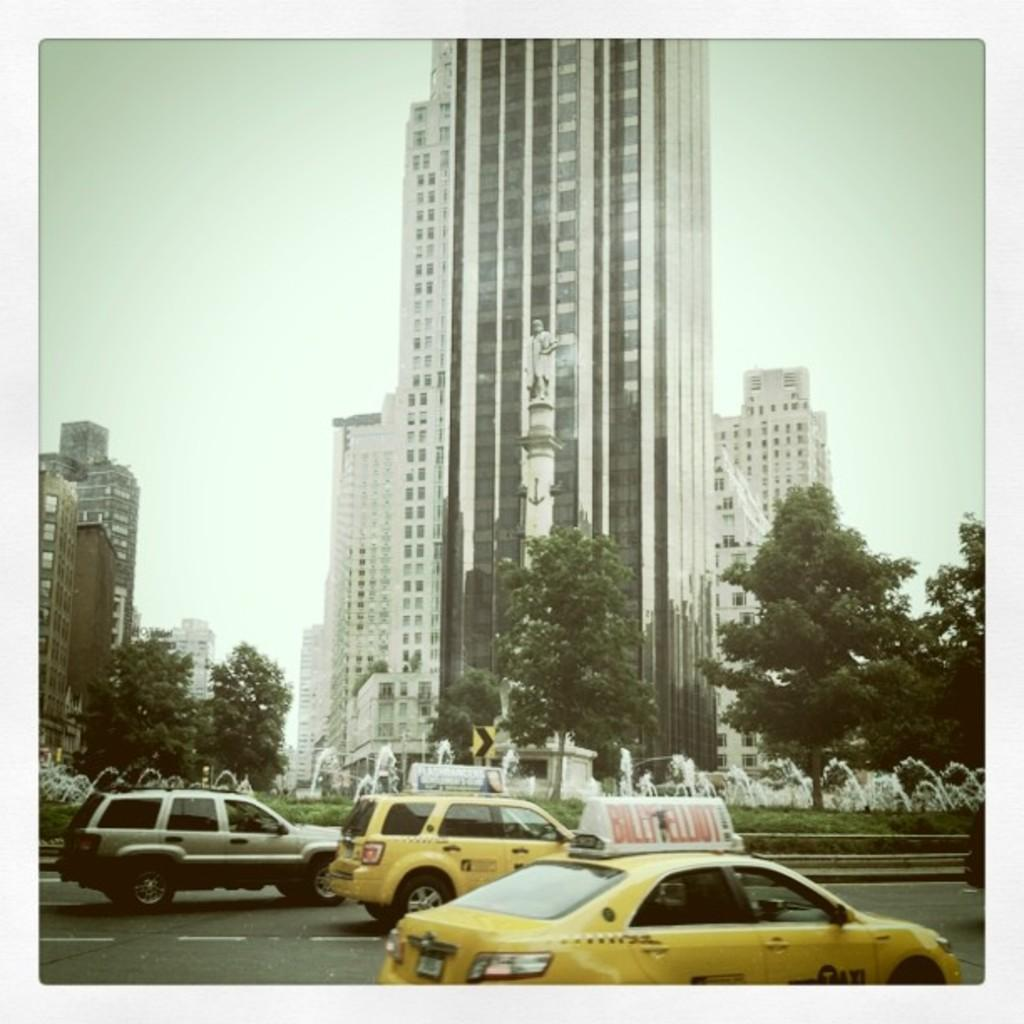<image>
Relay a brief, clear account of the picture shown. the name Billy is on the sign above the taxi 